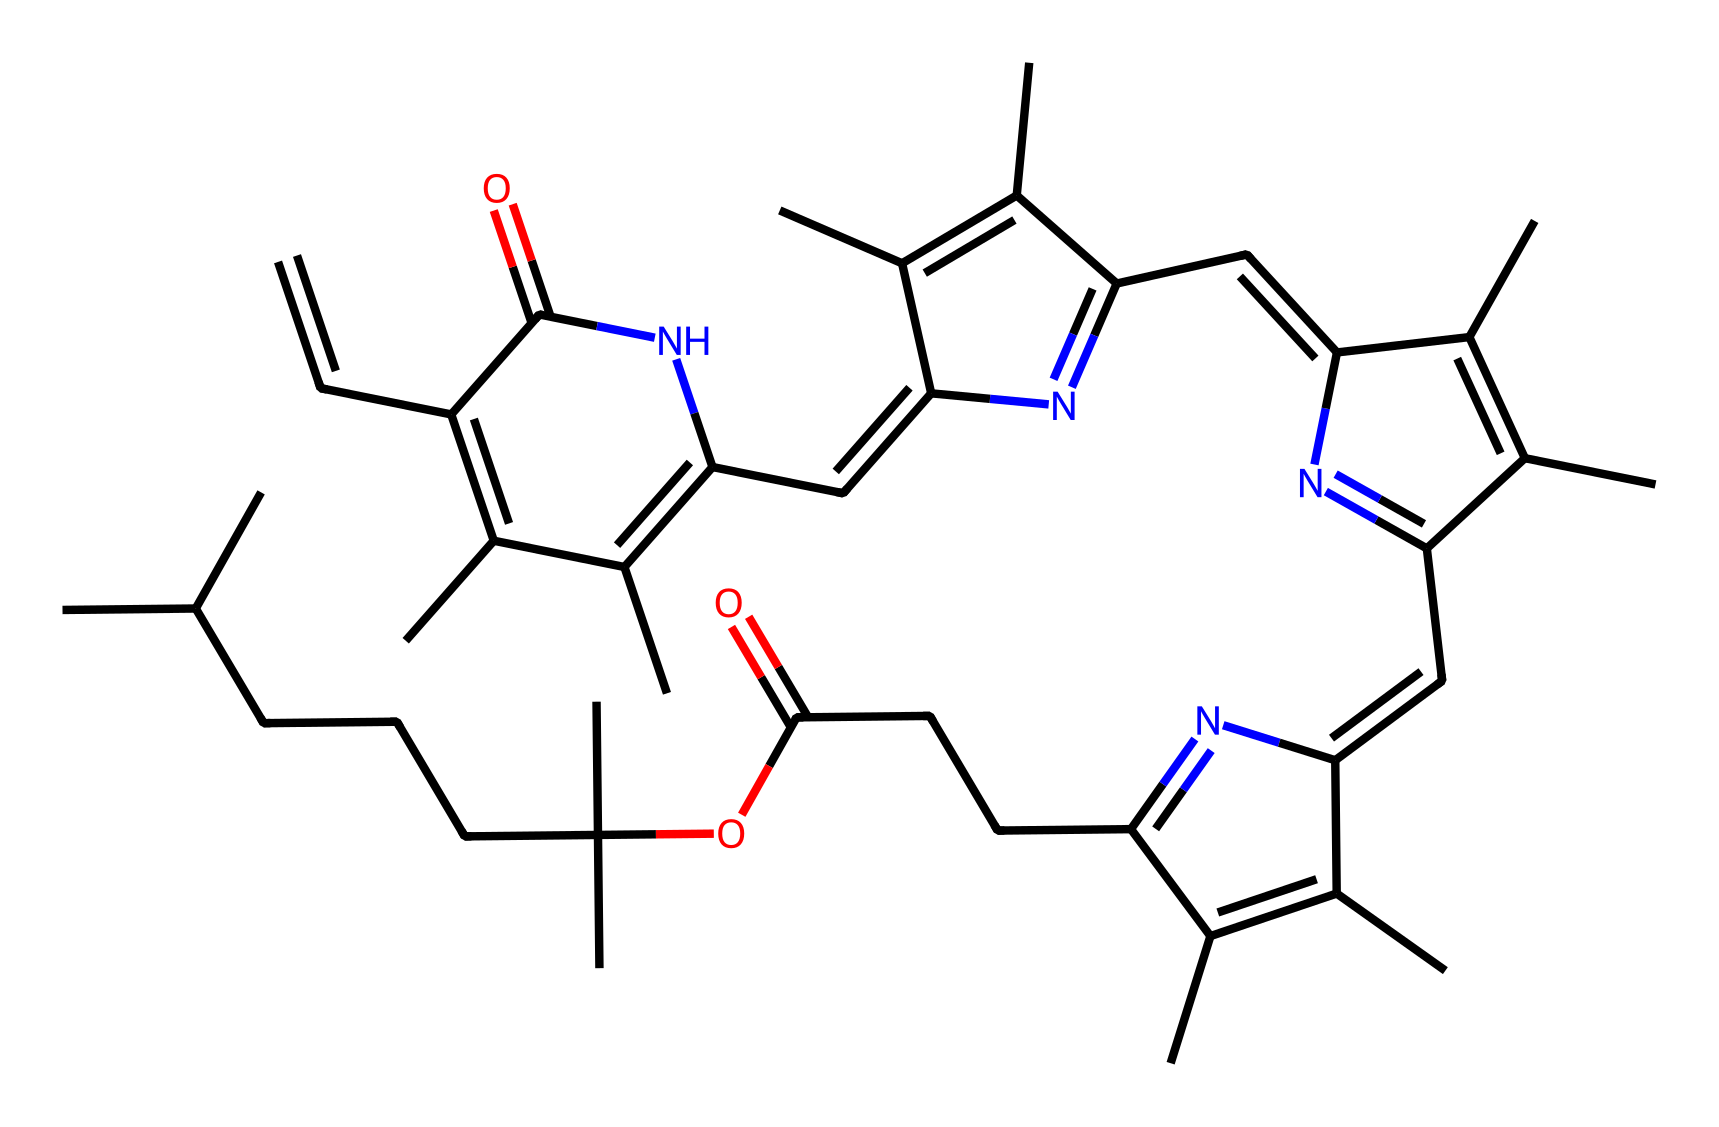What is the molecular formula of chlorophyll? The chemical structure can be analyzed to count the number of carbon (C), hydrogen (H), nitrogen (N), and oxygen (O) atoms. Upon inspection, there are 41 carbons, 55 hydrogens, 4 nitrogens, and 4 oxygens present in the structure. Therefore, the molecular formula is C41H55N4O4.
Answer: C41H55N4O4 How many nitrogen atoms are present in the chemical structure? By examining the SMILES representation, we can identify the nitrogen atoms (N). There are four instances of the nitrogen atom in the chemical structure, confirming the count.
Answer: 4 What role does chlorophyll play in photosynthesis? Chlorophyll primarily functions as a pigment that captures light energy from the sun, which is then used to convert carbon dioxide and water into glucose during photosynthesis.
Answer: pigment Is this chemical polar or non-polar? Considering the presence of various functional groups in the structure, including nitrogen and oxygen atoms, chlorophyll is characterized by polar regions alongside its large non-polar hydrocarbon tail, giving it a mixed polarity.
Answer: mixed What is the largest functional group present in chlorophyll? Upon analyzing the structure, the largest functional group would be the porphyrin ring, which consists of interconnected carbon atoms and nitrogen atoms, central to chlorophyll's function.
Answer: porphyrin ring Which part of the molecule interacts with light? The porphyrin ring of chlorophyll contains conjugated double bonds that allow for the absorption of light, specifically in the blue and red wavelengths, facilitating the process of photosynthesis.
Answer: porphyrin ring How does chlorophyll contribute to the green color of plants? The chlorophyll molecule absorbs light primarily in the blue and red regions of the spectrum, while reflecting green light, which results in the green appearance of plants.
Answer: absorbs blue and red, reflects green 